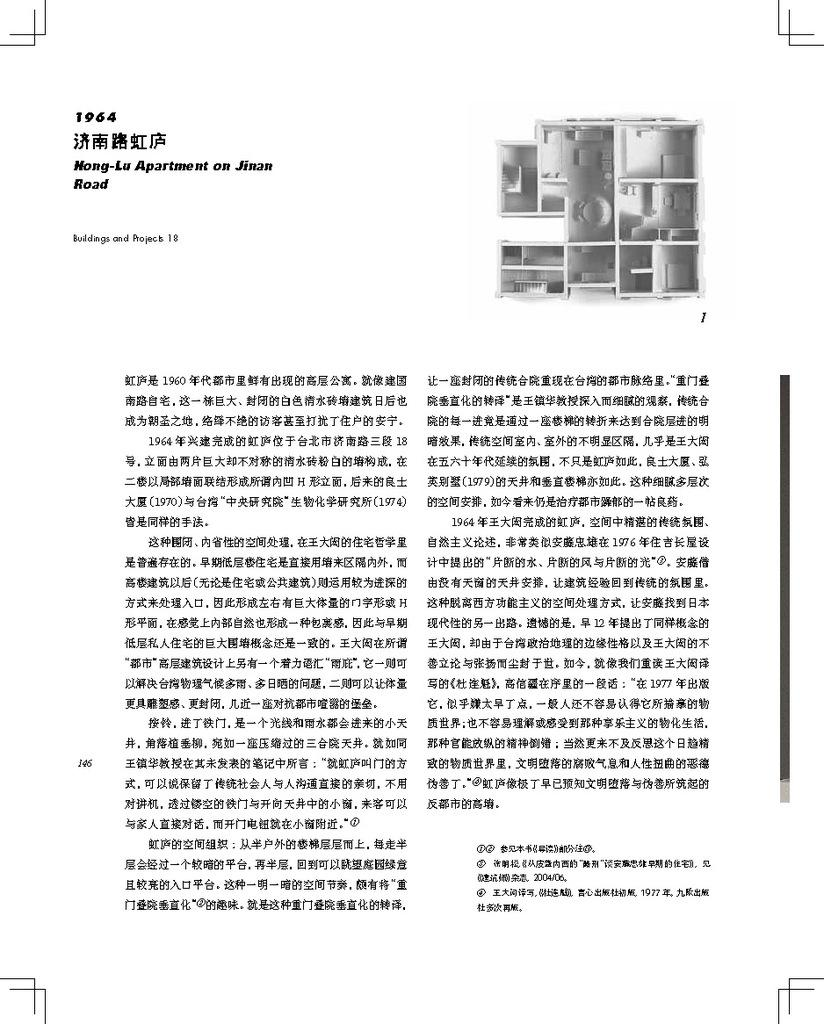<image>
Write a terse but informative summary of the picture. Document about building property written in Chinese characters with a picture of a building. 